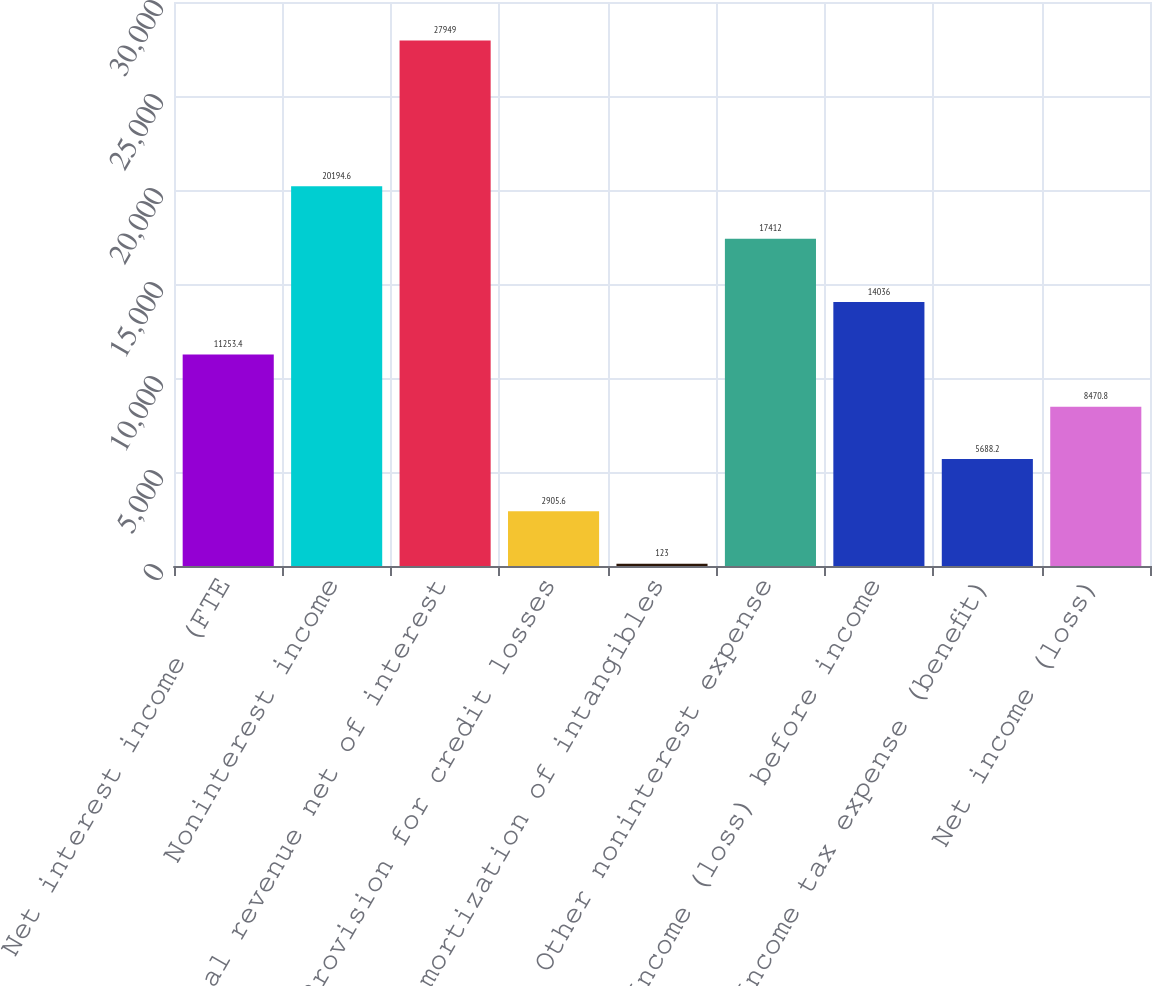Convert chart. <chart><loc_0><loc_0><loc_500><loc_500><bar_chart><fcel>Net interest income (FTE<fcel>Noninterest income<fcel>Total revenue net of interest<fcel>Provision for credit losses<fcel>Amortization of intangibles<fcel>Other noninterest expense<fcel>Income (loss) before income<fcel>Income tax expense (benefit)<fcel>Net income (loss)<nl><fcel>11253.4<fcel>20194.6<fcel>27949<fcel>2905.6<fcel>123<fcel>17412<fcel>14036<fcel>5688.2<fcel>8470.8<nl></chart> 